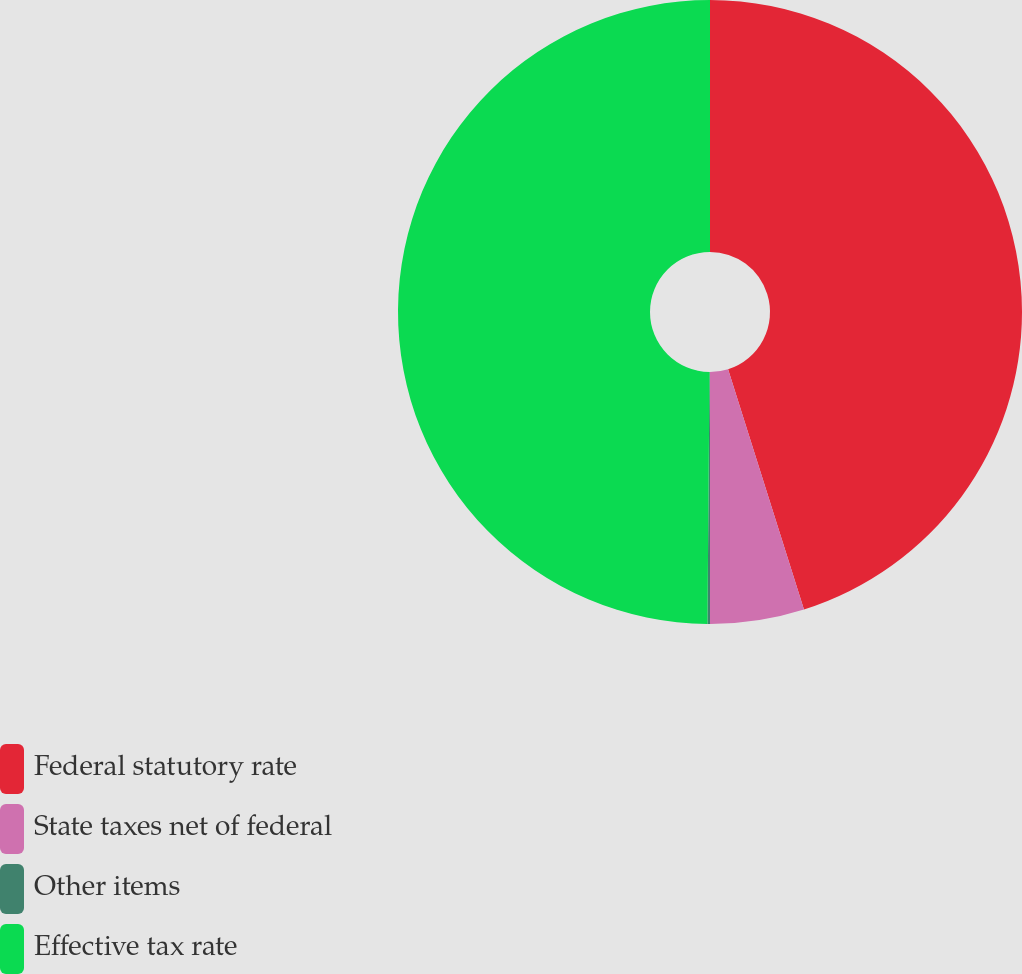Convert chart to OTSL. <chart><loc_0><loc_0><loc_500><loc_500><pie_chart><fcel>Federal statutory rate<fcel>State taxes net of federal<fcel>Other items<fcel>Effective tax rate<nl><fcel>45.13%<fcel>4.87%<fcel>0.13%<fcel>49.87%<nl></chart> 